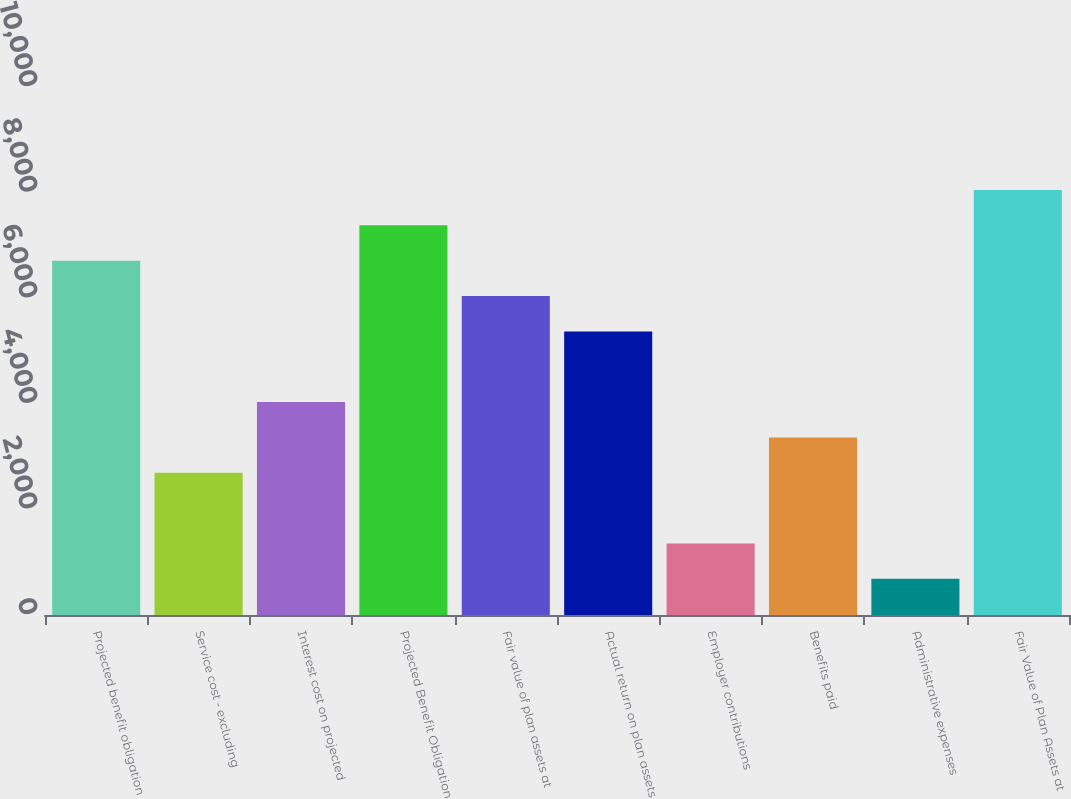Convert chart to OTSL. <chart><loc_0><loc_0><loc_500><loc_500><bar_chart><fcel>Projected benefit obligation<fcel>Service cost - excluding<fcel>Interest cost on projected<fcel>Projected Benefit Obligation<fcel>Fair value of plan assets at<fcel>Actual return on plan assets<fcel>Employer contributions<fcel>Benefits paid<fcel>Administrative expenses<fcel>Fair Value of Plan Assets at<nl><fcel>6710<fcel>2693<fcel>4032<fcel>7379.5<fcel>6040.5<fcel>5371<fcel>1354<fcel>3362.5<fcel>684.5<fcel>8049<nl></chart> 